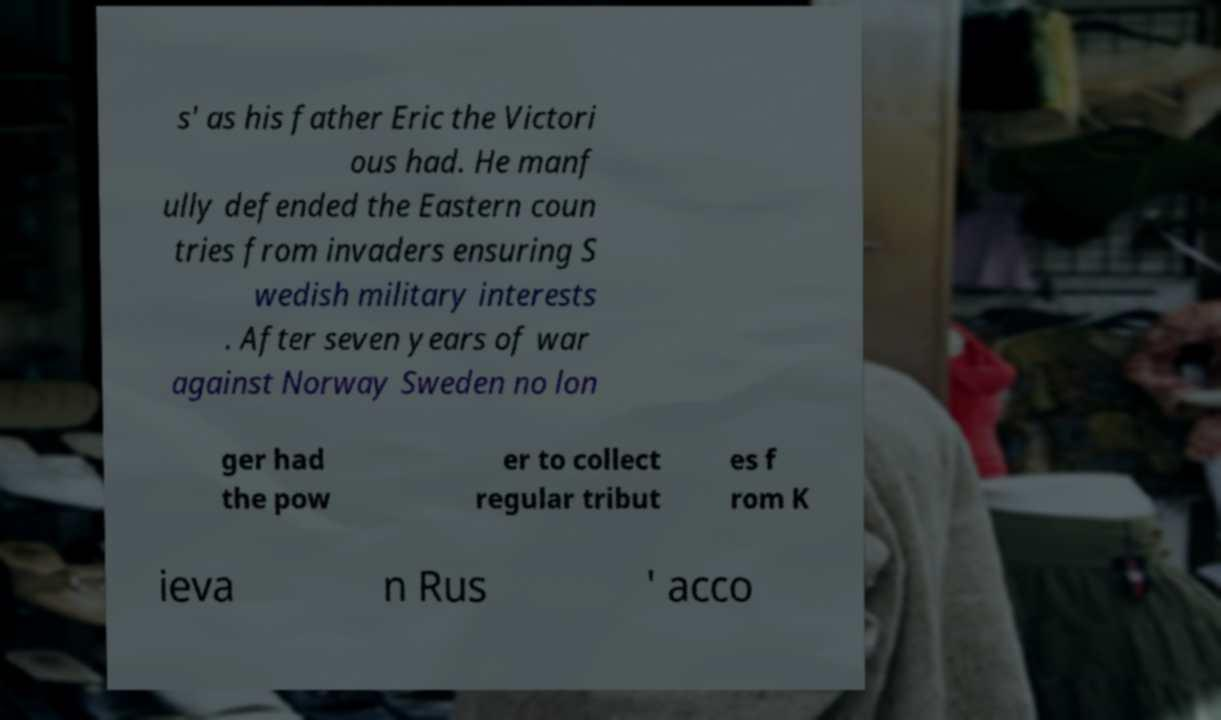Please read and relay the text visible in this image. What does it say? s' as his father Eric the Victori ous had. He manf ully defended the Eastern coun tries from invaders ensuring S wedish military interests . After seven years of war against Norway Sweden no lon ger had the pow er to collect regular tribut es f rom K ieva n Rus ' acco 